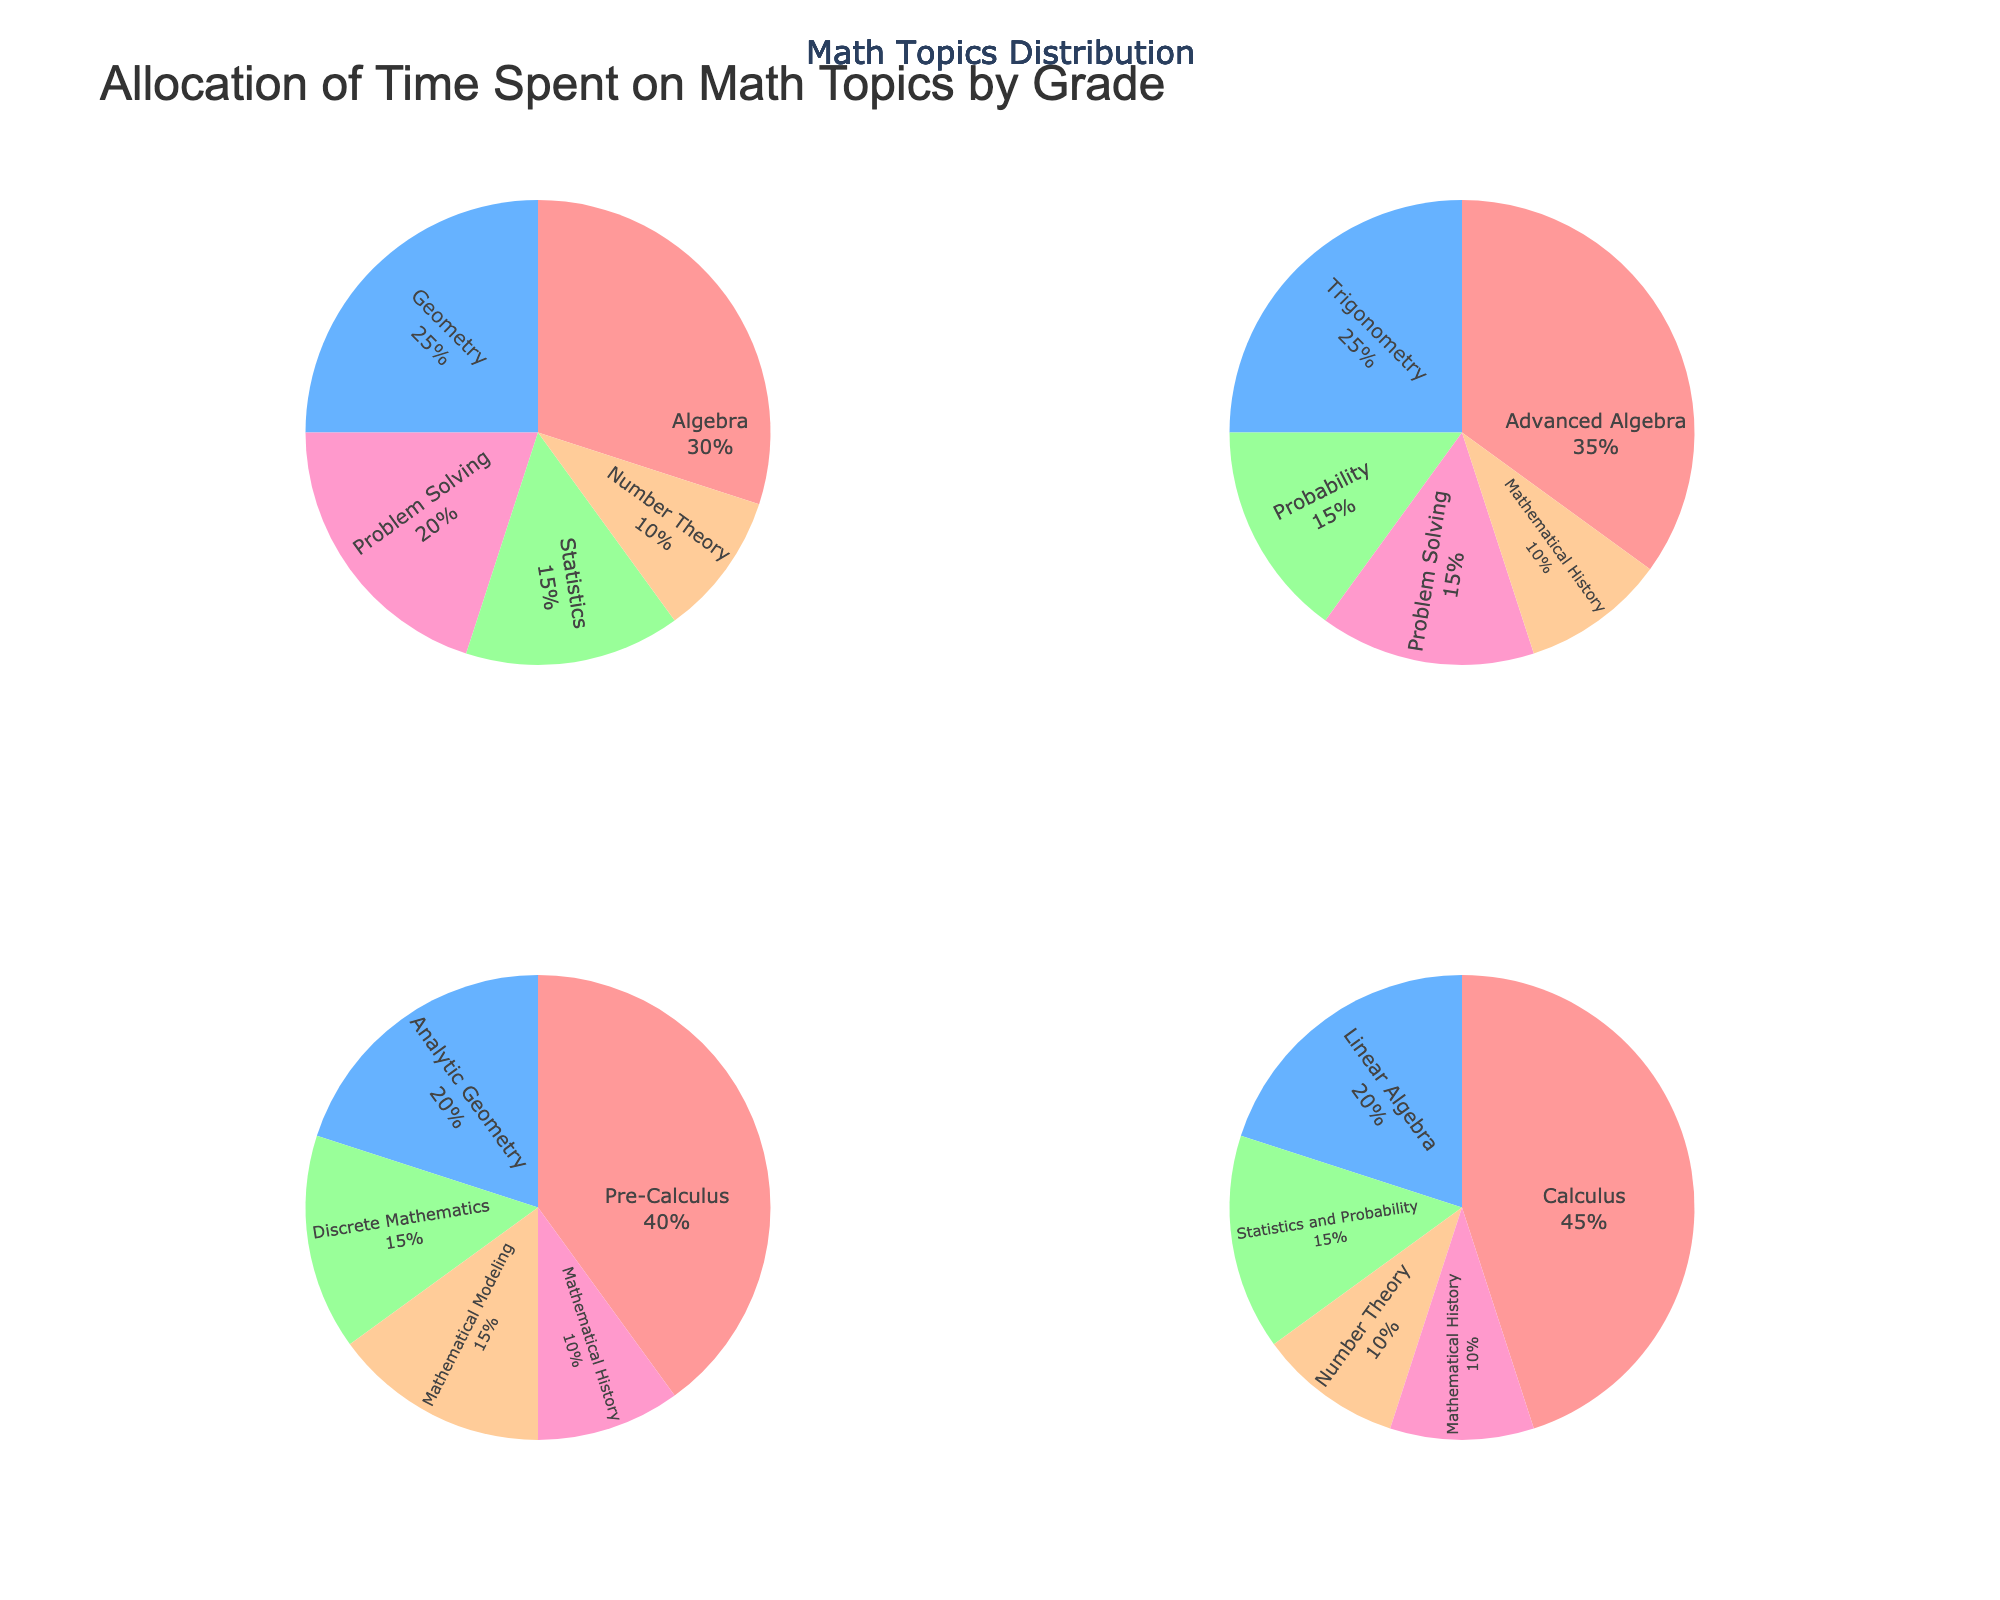What is the title of the plot? The title of the plot is usually displayed at the top of the figure. In this case, it is "Allocation of Time Spent on Math Topics by Grade."
Answer: Allocation of Time Spent on Math Topics by Grade Which grade spent the most time on Calculus? Each pie chart represents a different grade, and the titles of the subplots indicate the grades. By looking at the 12th Grade pie chart, it is clear that Calculus occupies the largest portion of the pie, indicating the most time spent.
Answer: 12th Grade How much time is allocated to problem-solving topics in total? First, identify the portions allocated to problem-solving topics in all grades. Summed up, 9th Grade has 20%, 10th Grade has 15%, and other grades do not allocate time to problem-solving. Add them up: 20% + 15% = 35%.
Answer: 35% Which grade has the highest percentage dedicated to a single topic? Each pie chart shows different percentages for topics. The 12th Grade chart shows a 45% slice for Calculus, which is the highest percentage for a single topic among all grades.
Answer: 12th Grade Compare the time spent on Number Theory in 9th Grade and 12th Grade. Which grade spends more time on Number Theory? Checking the slices for Number Theory in both the 9th Grade and 12th Grade charts, we see that both grades allocate 10% of their time to this topic.
Answer: Equal What is the average percentage of time spent on Mathematical History across all grades? Mathematical History time is given as 10% for each of 10th, 11th, and 12th Grade. Only three grades allocate time to this topic. Calculate the average: (10% + 10% + 10%) / 3 = 10%.
Answer: 10% Which topic receives the least amount of time in 11th Grade? Analyzing the 11th Grade pie chart, we examine all the slices. The smallest portion is for Mathematical History, which receives 10%.
Answer: Mathematical History How does the time allocation for Statistics and Probability in 12th Grade compare to 9th Grade? The 12th Grade pie chart shows a combined section for Statistics and Probability at 15%, while the 9th Grade pie chart shows Statistics at 15%. Since 12th Grade combines both topics, the percentage is the same when compared individually to 9th Grade Statistics.
Answer: Equal What percentage of time is spent on Geometry topics across all grades combined? From the data, Geometry is allocated time in the 9th Grade at 25% and Analytic Geometry in 11th Grade at 20%. Sum these values: 25% + 20% = 45%.
Answer: 45% 